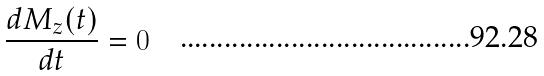Convert formula to latex. <formula><loc_0><loc_0><loc_500><loc_500>\frac { d M _ { z } ( t ) } { d t } = 0</formula> 